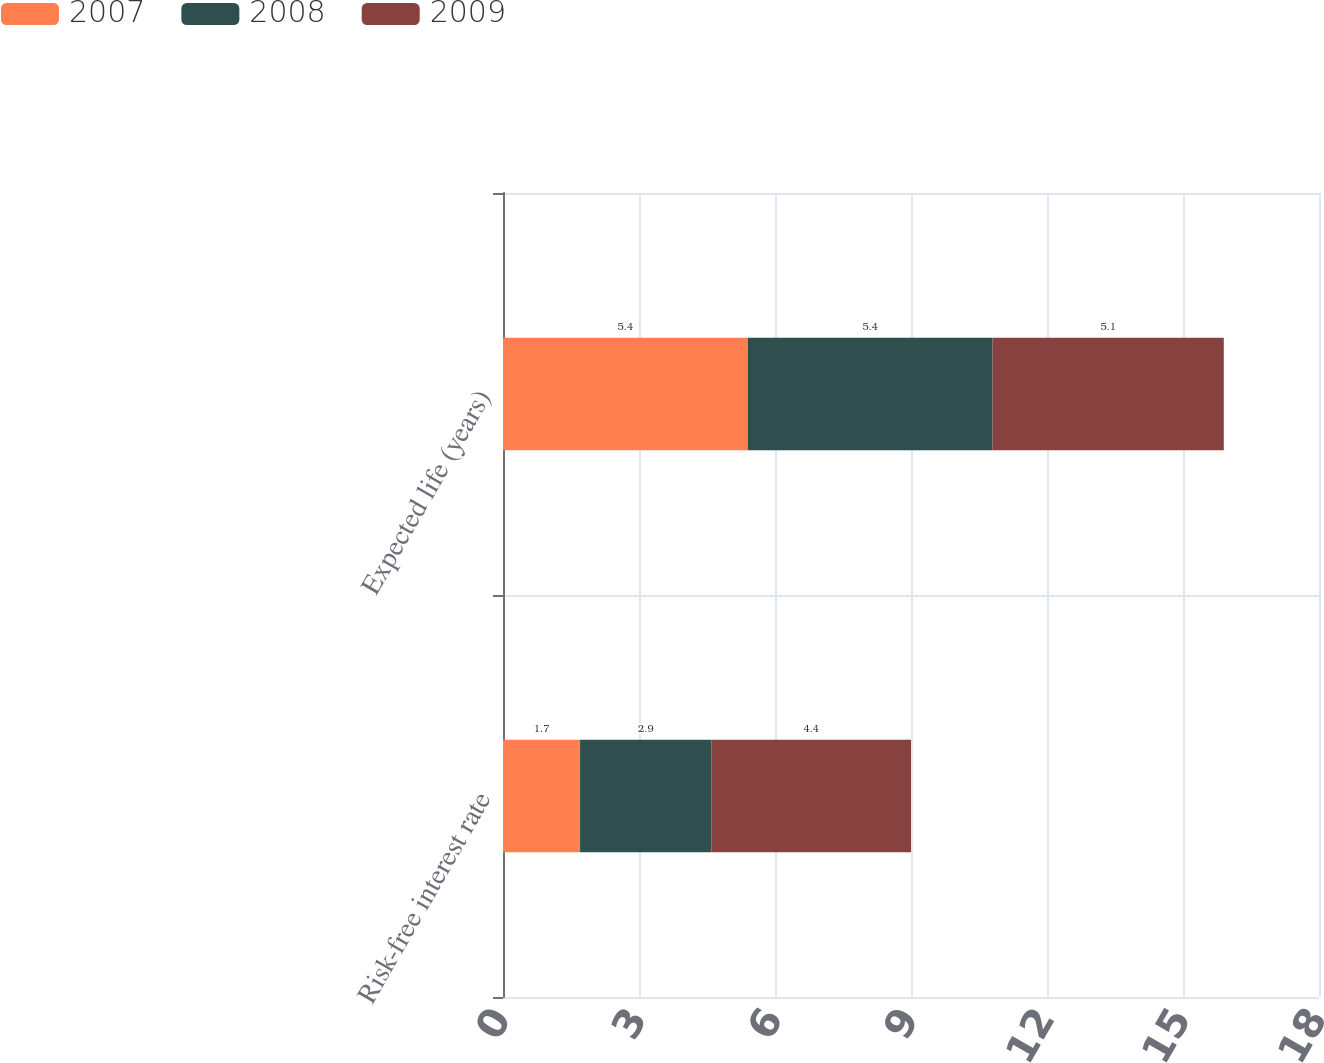Convert chart. <chart><loc_0><loc_0><loc_500><loc_500><stacked_bar_chart><ecel><fcel>Risk-free interest rate<fcel>Expected life (years)<nl><fcel>2007<fcel>1.7<fcel>5.4<nl><fcel>2008<fcel>2.9<fcel>5.4<nl><fcel>2009<fcel>4.4<fcel>5.1<nl></chart> 